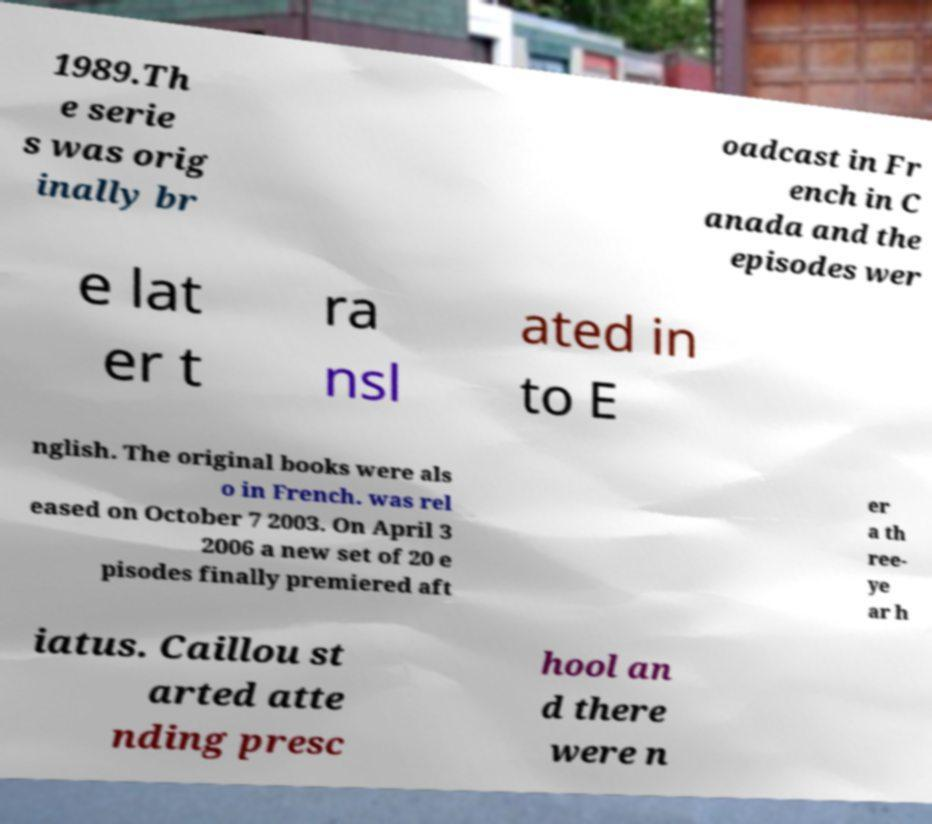Can you read and provide the text displayed in the image?This photo seems to have some interesting text. Can you extract and type it out for me? 1989.Th e serie s was orig inally br oadcast in Fr ench in C anada and the episodes wer e lat er t ra nsl ated in to E nglish. The original books were als o in French. was rel eased on October 7 2003. On April 3 2006 a new set of 20 e pisodes finally premiered aft er a th ree- ye ar h iatus. Caillou st arted atte nding presc hool an d there were n 